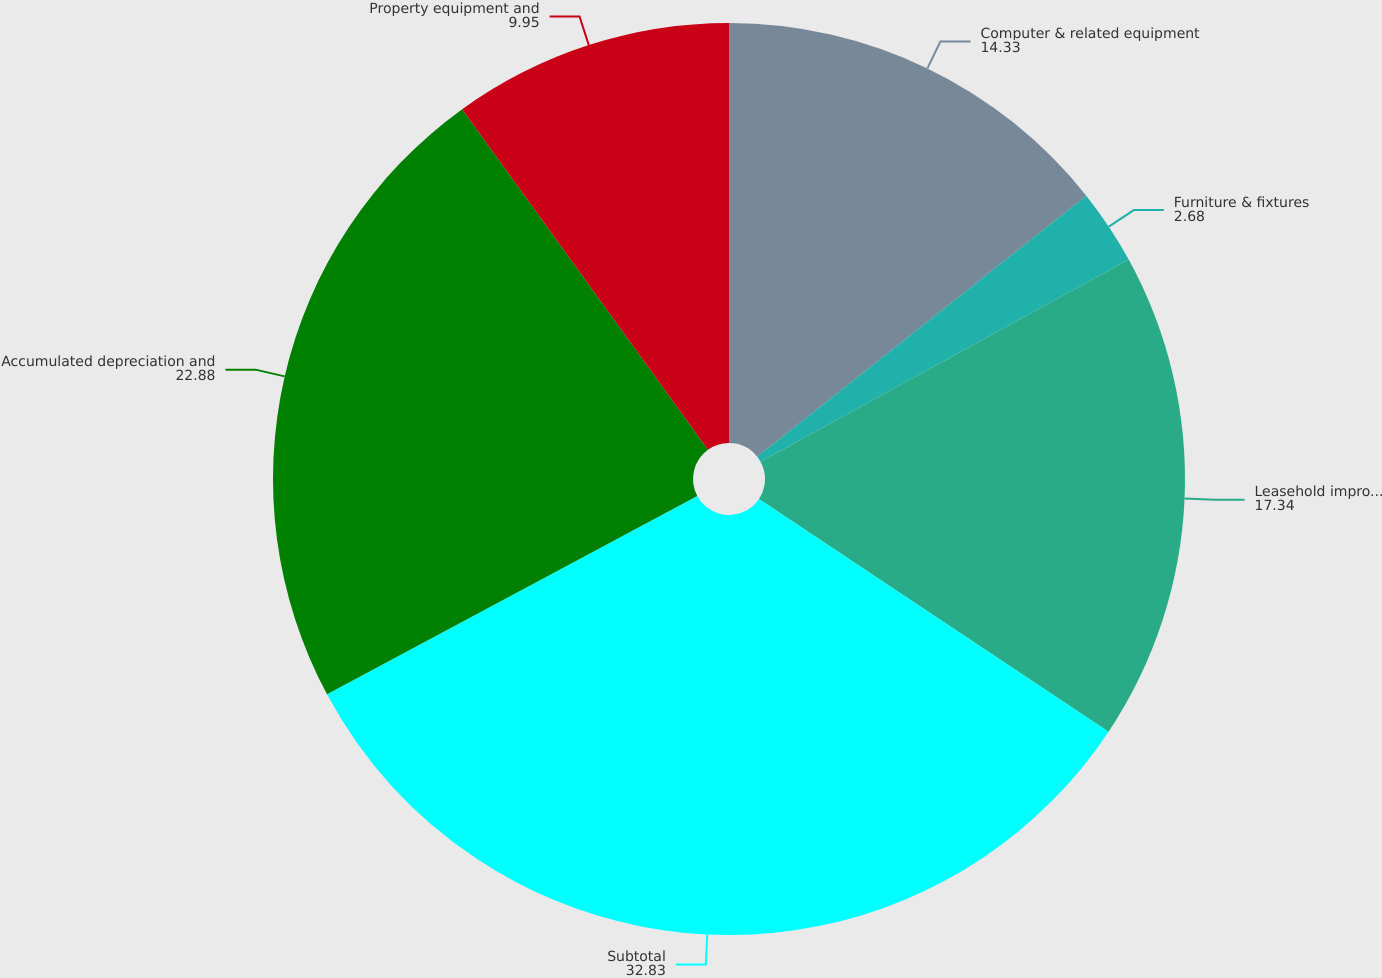Convert chart to OTSL. <chart><loc_0><loc_0><loc_500><loc_500><pie_chart><fcel>Computer & related equipment<fcel>Furniture & fixtures<fcel>Leasehold improvements<fcel>Subtotal<fcel>Accumulated depreciation and<fcel>Property equipment and<nl><fcel>14.33%<fcel>2.68%<fcel>17.34%<fcel>32.83%<fcel>22.88%<fcel>9.95%<nl></chart> 